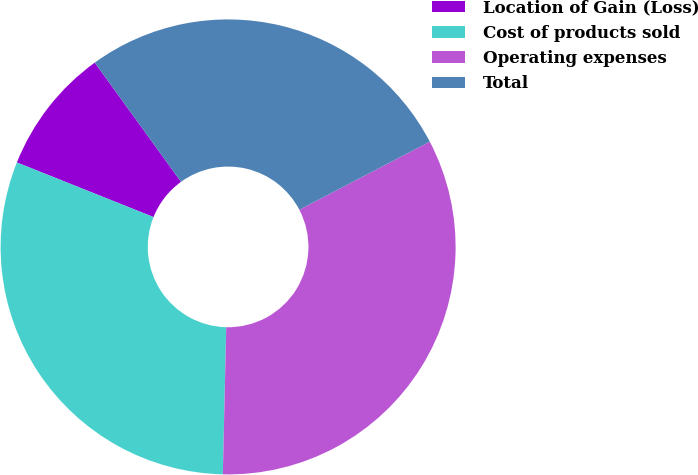<chart> <loc_0><loc_0><loc_500><loc_500><pie_chart><fcel>Location of Gain (Loss)<fcel>Cost of products sold<fcel>Operating expenses<fcel>Total<nl><fcel>8.98%<fcel>30.68%<fcel>33.02%<fcel>27.31%<nl></chart> 